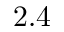<formula> <loc_0><loc_0><loc_500><loc_500>2 . 4</formula> 